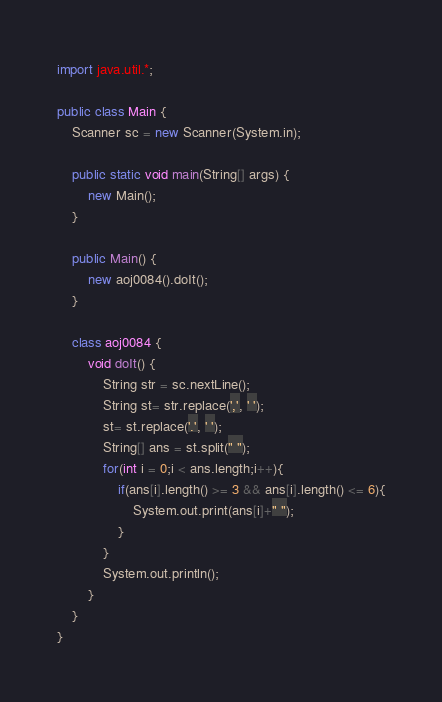Convert code to text. <code><loc_0><loc_0><loc_500><loc_500><_Java_>import java.util.*;

public class Main {
	Scanner sc = new Scanner(System.in);

	public static void main(String[] args) {
		new Main();
	}

	public Main() {
		new aoj0084().doIt();
	}

	class aoj0084 {
		void doIt() {
			String str = sc.nextLine();
			String st= str.replace(',', ' ');
			st= st.replace('.', ' ');
			String[] ans = st.split(" ");
			for(int i = 0;i < ans.length;i++){
				if(ans[i].length() >= 3 && ans[i].length() <= 6){
					System.out.print(ans[i]+" ");
				}
			}
			System.out.println();
		}
	}
}</code> 